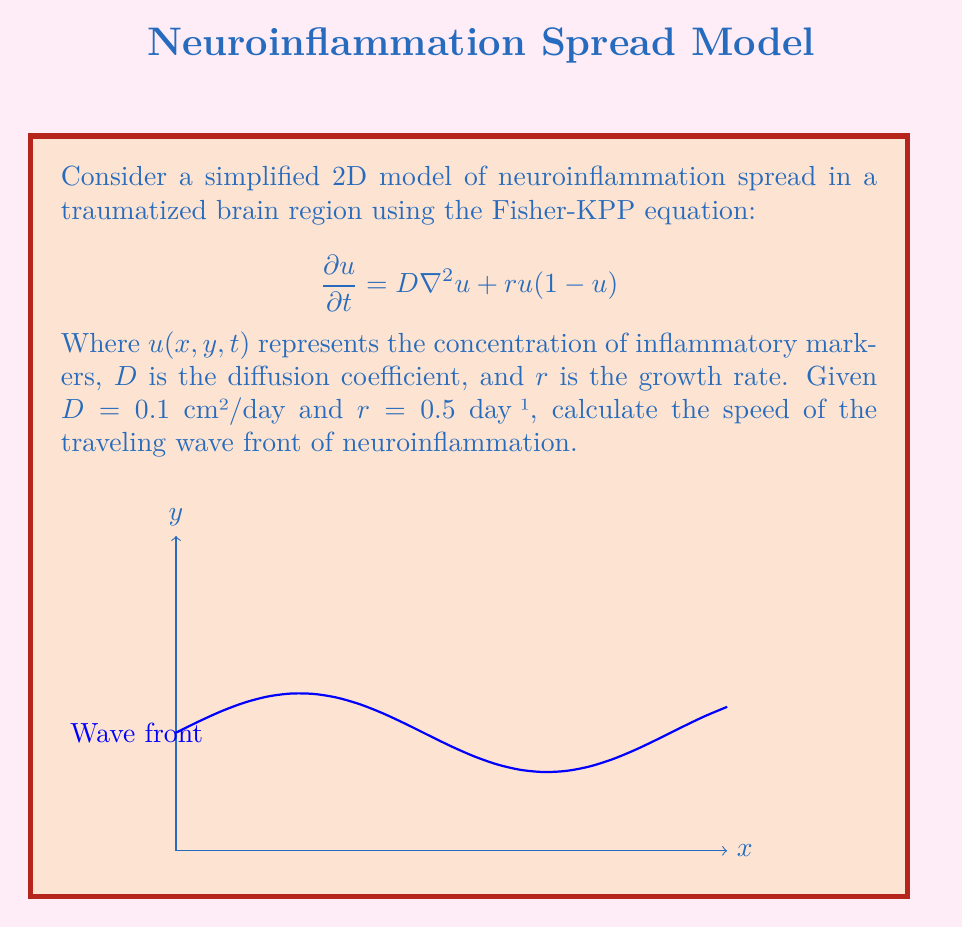Solve this math problem. To solve this problem, we'll follow these steps:

1) The Fisher-KPP equation is a reaction-diffusion equation that models the spread of a population (in this case, inflammatory markers) in space and time.

2) For this equation, it's known that the speed of the traveling wave front is given by:

   $$c = 2\sqrt{Dr}$$

3) We're given:
   $D = 0.1$ cm²/day
   $r = 0.5$ day⁻¹

4) Let's substitute these values into the equation:

   $$c = 2\sqrt{(0.1\text{ cm²/day})(0.5\text{ day⁻¹})}$$

5) Simplify under the square root:

   $$c = 2\sqrt{0.05\text{ cm²/day²}}$$

6) Calculate:

   $$c = 2(0.2236\text{ cm/day}) = 0.4472\text{ cm/day}$$

7) Round to three decimal places:

   $$c \approx 0.447\text{ cm/day}$$
Answer: $0.447\text{ cm/day}$ 